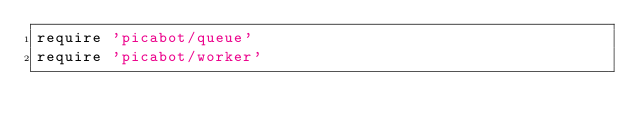Convert code to text. <code><loc_0><loc_0><loc_500><loc_500><_Ruby_>require 'picabot/queue'
require 'picabot/worker'
</code> 